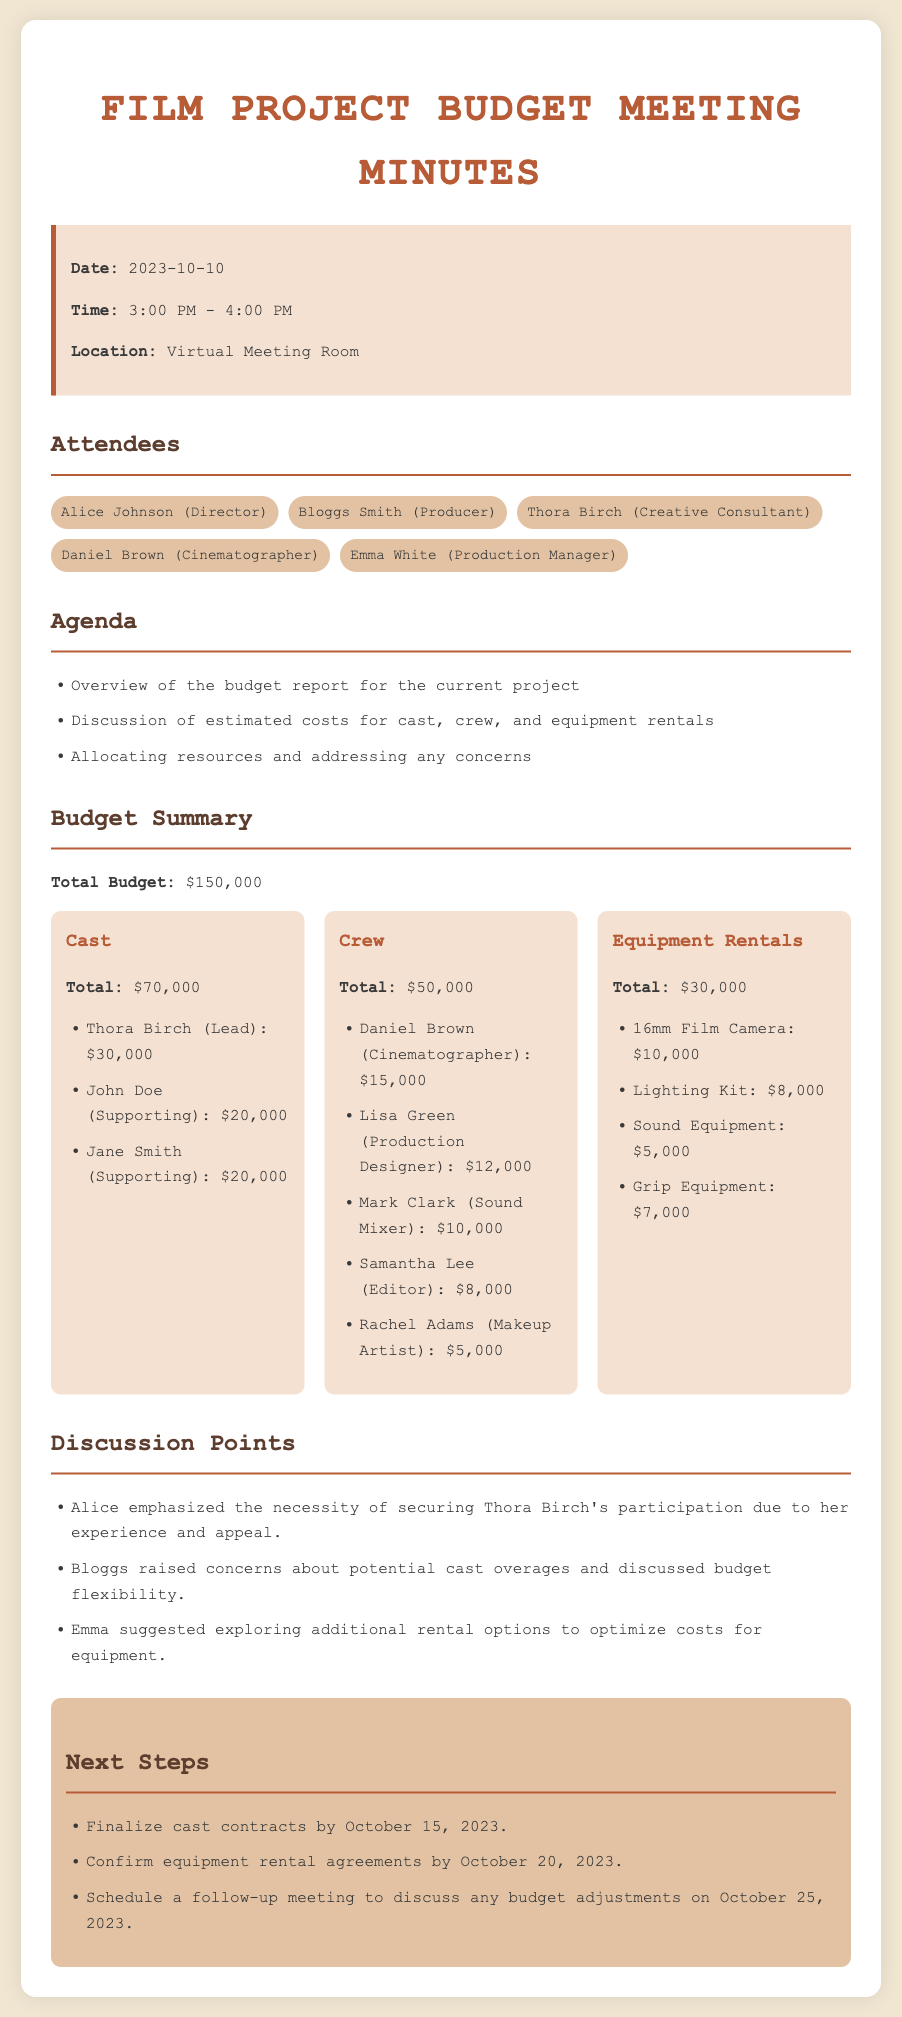What is the date of the meeting? The date of the meeting is specified in the info box of the document.
Answer: 2023-10-10 Who is the creative consultant listed in the attendees? Thora Birch is mentioned as the creative consultant among the attendees.
Answer: Thora Birch What is the total budget for the project? The total budget is clearly stated in the budget summary section of the document.
Answer: $150,000 How much is allocated for cast expenses? The total cast expenses are detailed in the budget summary, specifically under the cast section.
Answer: $70,000 What is the name of the cinematographer? The name of the cinematographer is listed in the crew section of the budget summary.
Answer: Daniel Brown What was discussed regarding the budget flexibility? Bloggs raised concerns about potential cast overages and budget flexibility is mentioned as a discussion point.
Answer: Budget flexibility What is the deadline for finalizing cast contracts? The deadline for finalizing cast contracts is outlined in the next steps section.
Answer: October 15, 2023 How much is budgeted for equipment rentals? The total amount reserved for equipment rentals is specifically mentioned in the budget summary section.
Answer: $30,000 What was suggested to optimize costs for equipment? Emma's suggestion to explore additional rental options is noted in the discussion points of the document.
Answer: Additional rental options 